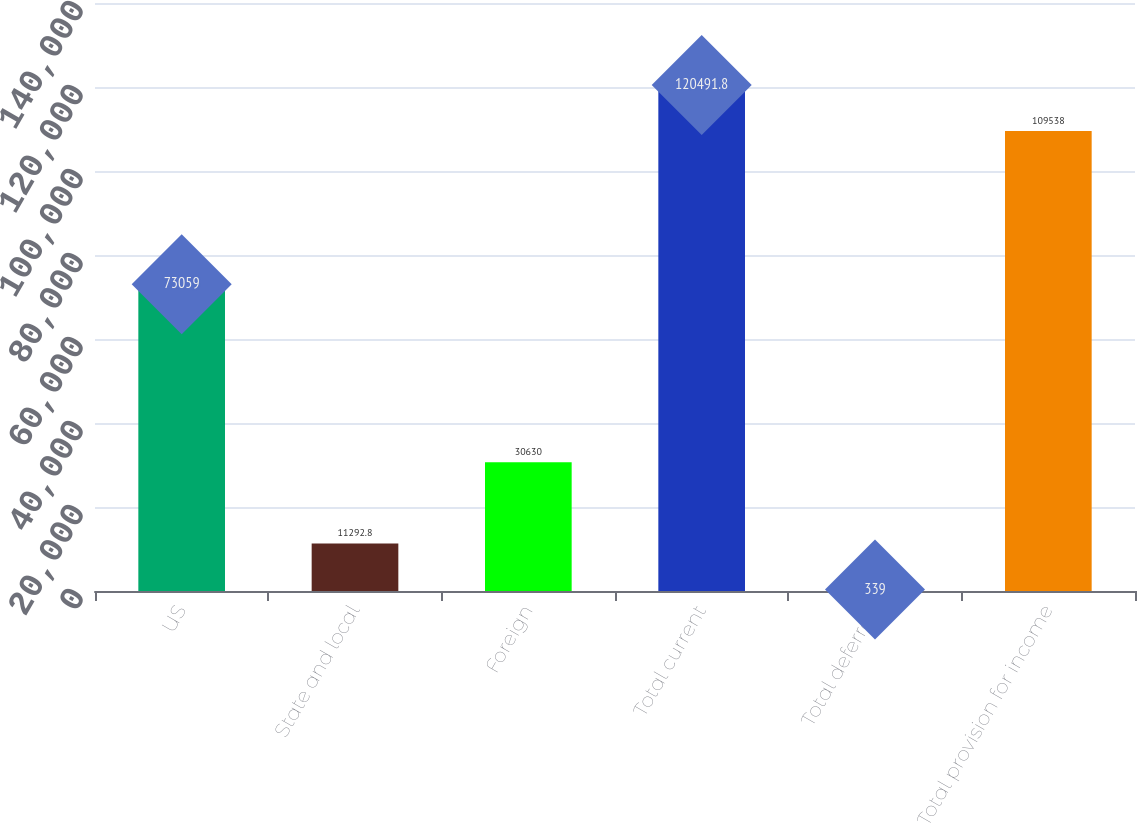Convert chart. <chart><loc_0><loc_0><loc_500><loc_500><bar_chart><fcel>US<fcel>State and local<fcel>Foreign<fcel>Total current<fcel>Total deferred<fcel>Total provision for income<nl><fcel>73059<fcel>11292.8<fcel>30630<fcel>120492<fcel>339<fcel>109538<nl></chart> 